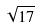Convert formula to latex. <formula><loc_0><loc_0><loc_500><loc_500>\sqrt { 1 7 }</formula> 